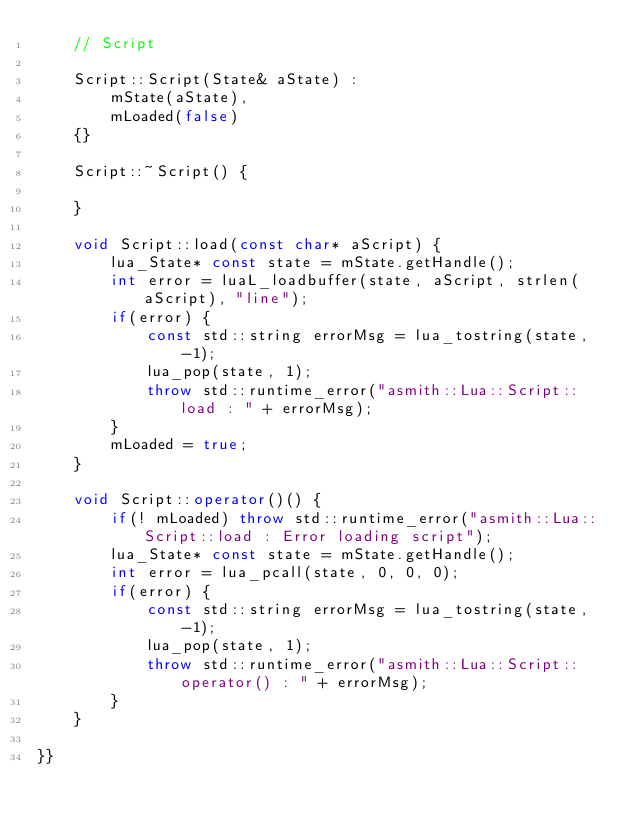<code> <loc_0><loc_0><loc_500><loc_500><_C++_>	// Script

	Script::Script(State& aState) :
		mState(aState),
		mLoaded(false)
	{}

	Script::~Script() {

	}

	void Script::load(const char* aScript) {
		lua_State* const state = mState.getHandle();
		int error = luaL_loadbuffer(state, aScript, strlen(aScript), "line");
		if(error) {
			const std::string errorMsg = lua_tostring(state, -1);
			lua_pop(state, 1);
			throw std::runtime_error("asmith::Lua::Script::load : " + errorMsg);
		}
		mLoaded = true;
	}

	void Script::operator()() {
		if(! mLoaded) throw std::runtime_error("asmith::Lua::Script::load : Error loading script"); 
		lua_State* const state = mState.getHandle();
		int error = lua_pcall(state, 0, 0, 0);
		if(error) {
			const std::string errorMsg = lua_tostring(state, -1);
			lua_pop(state, 1);
			throw std::runtime_error("asmith::Lua::Script::operator() : " + errorMsg);
		}
	}

}}</code> 